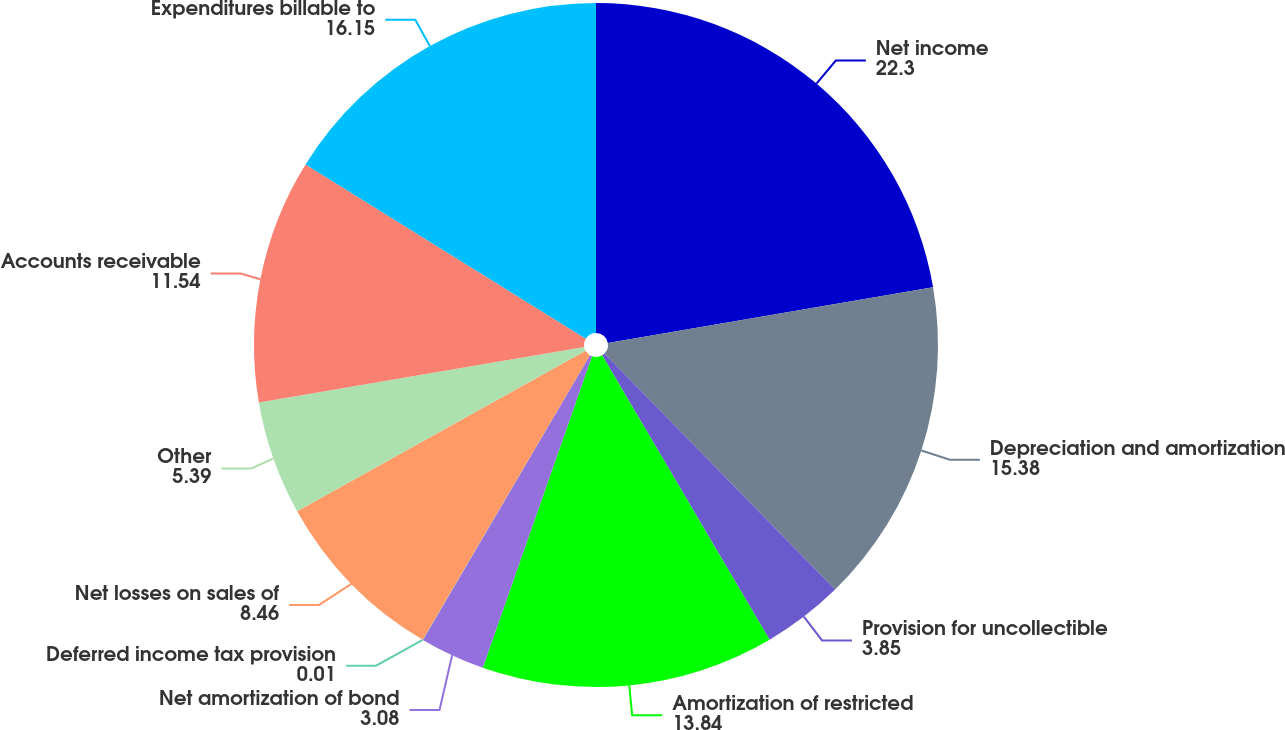<chart> <loc_0><loc_0><loc_500><loc_500><pie_chart><fcel>Net income<fcel>Depreciation and amortization<fcel>Provision for uncollectible<fcel>Amortization of restricted<fcel>Net amortization of bond<fcel>Deferred income tax provision<fcel>Net losses on sales of<fcel>Other<fcel>Accounts receivable<fcel>Expenditures billable to<nl><fcel>22.3%<fcel>15.38%<fcel>3.85%<fcel>13.84%<fcel>3.08%<fcel>0.01%<fcel>8.46%<fcel>5.39%<fcel>11.54%<fcel>16.15%<nl></chart> 